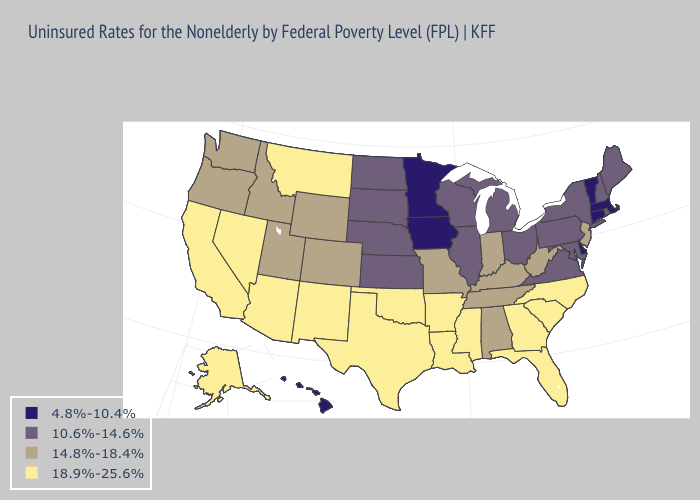Does New Hampshire have a lower value than Kansas?
Be succinct. No. Does New Hampshire have a higher value than West Virginia?
Keep it brief. No. Name the states that have a value in the range 4.8%-10.4%?
Quick response, please. Connecticut, Delaware, Hawaii, Iowa, Massachusetts, Minnesota, Vermont. Name the states that have a value in the range 10.6%-14.6%?
Be succinct. Illinois, Kansas, Maine, Maryland, Michigan, Nebraska, New Hampshire, New York, North Dakota, Ohio, Pennsylvania, Rhode Island, South Dakota, Virginia, Wisconsin. How many symbols are there in the legend?
Give a very brief answer. 4. What is the value of Texas?
Concise answer only. 18.9%-25.6%. Name the states that have a value in the range 4.8%-10.4%?
Be succinct. Connecticut, Delaware, Hawaii, Iowa, Massachusetts, Minnesota, Vermont. What is the highest value in the USA?
Be succinct. 18.9%-25.6%. Does the first symbol in the legend represent the smallest category?
Answer briefly. Yes. What is the value of Florida?
Give a very brief answer. 18.9%-25.6%. Name the states that have a value in the range 18.9%-25.6%?
Quick response, please. Alaska, Arizona, Arkansas, California, Florida, Georgia, Louisiana, Mississippi, Montana, Nevada, New Mexico, North Carolina, Oklahoma, South Carolina, Texas. Among the states that border Delaware , which have the lowest value?
Write a very short answer. Maryland, Pennsylvania. What is the value of Virginia?
Be succinct. 10.6%-14.6%. Does the first symbol in the legend represent the smallest category?
Answer briefly. Yes. Does the first symbol in the legend represent the smallest category?
Keep it brief. Yes. 